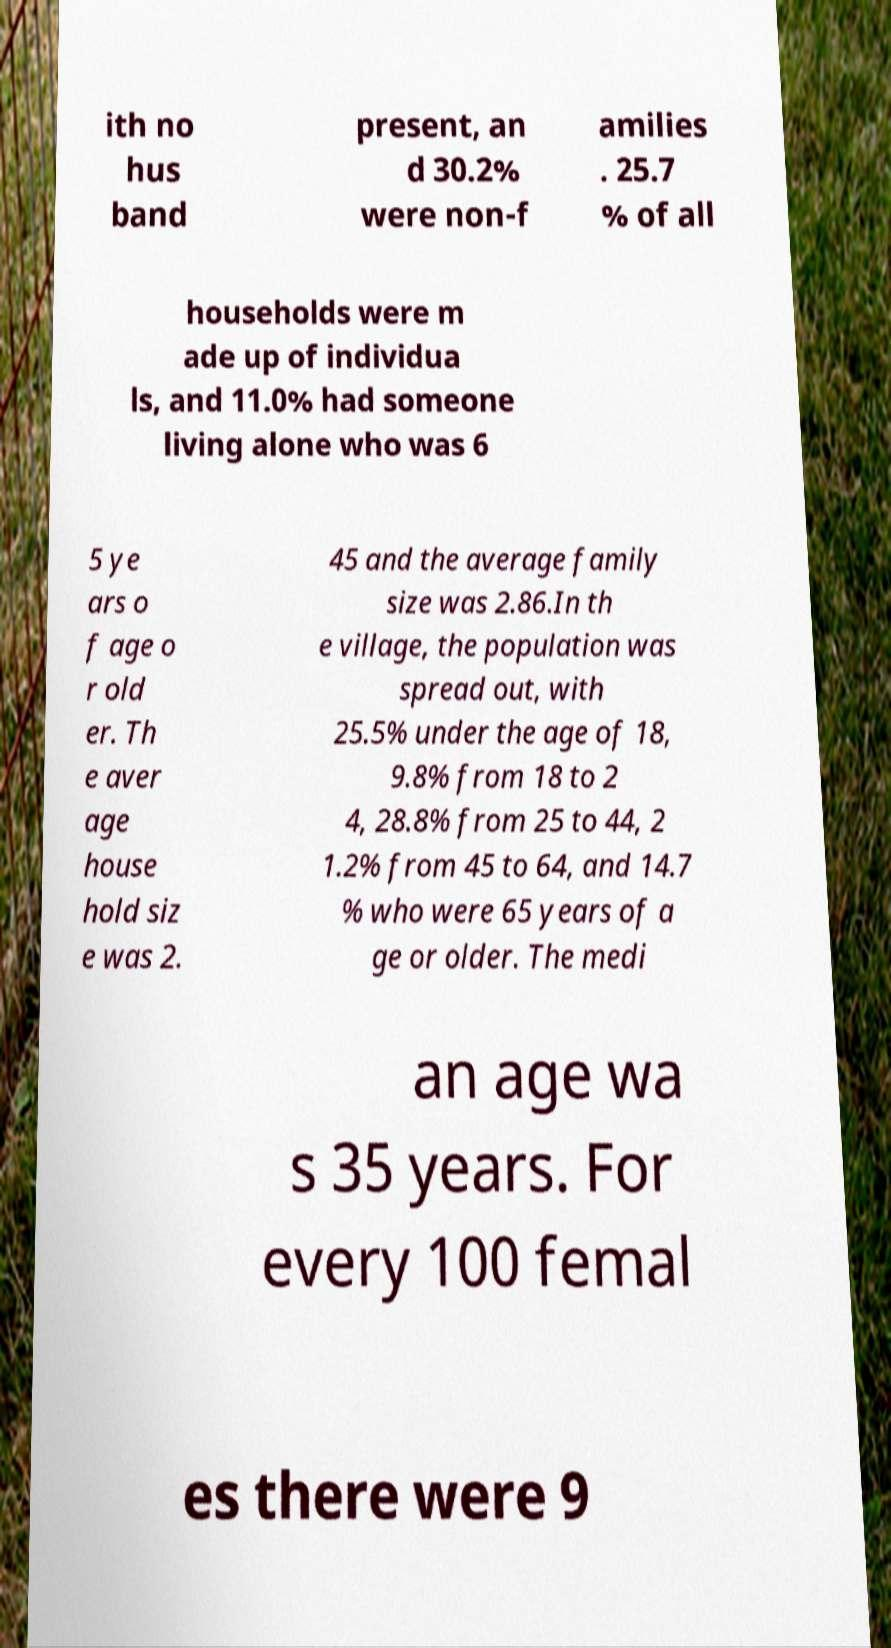There's text embedded in this image that I need extracted. Can you transcribe it verbatim? ith no hus band present, an d 30.2% were non-f amilies . 25.7 % of all households were m ade up of individua ls, and 11.0% had someone living alone who was 6 5 ye ars o f age o r old er. Th e aver age house hold siz e was 2. 45 and the average family size was 2.86.In th e village, the population was spread out, with 25.5% under the age of 18, 9.8% from 18 to 2 4, 28.8% from 25 to 44, 2 1.2% from 45 to 64, and 14.7 % who were 65 years of a ge or older. The medi an age wa s 35 years. For every 100 femal es there were 9 